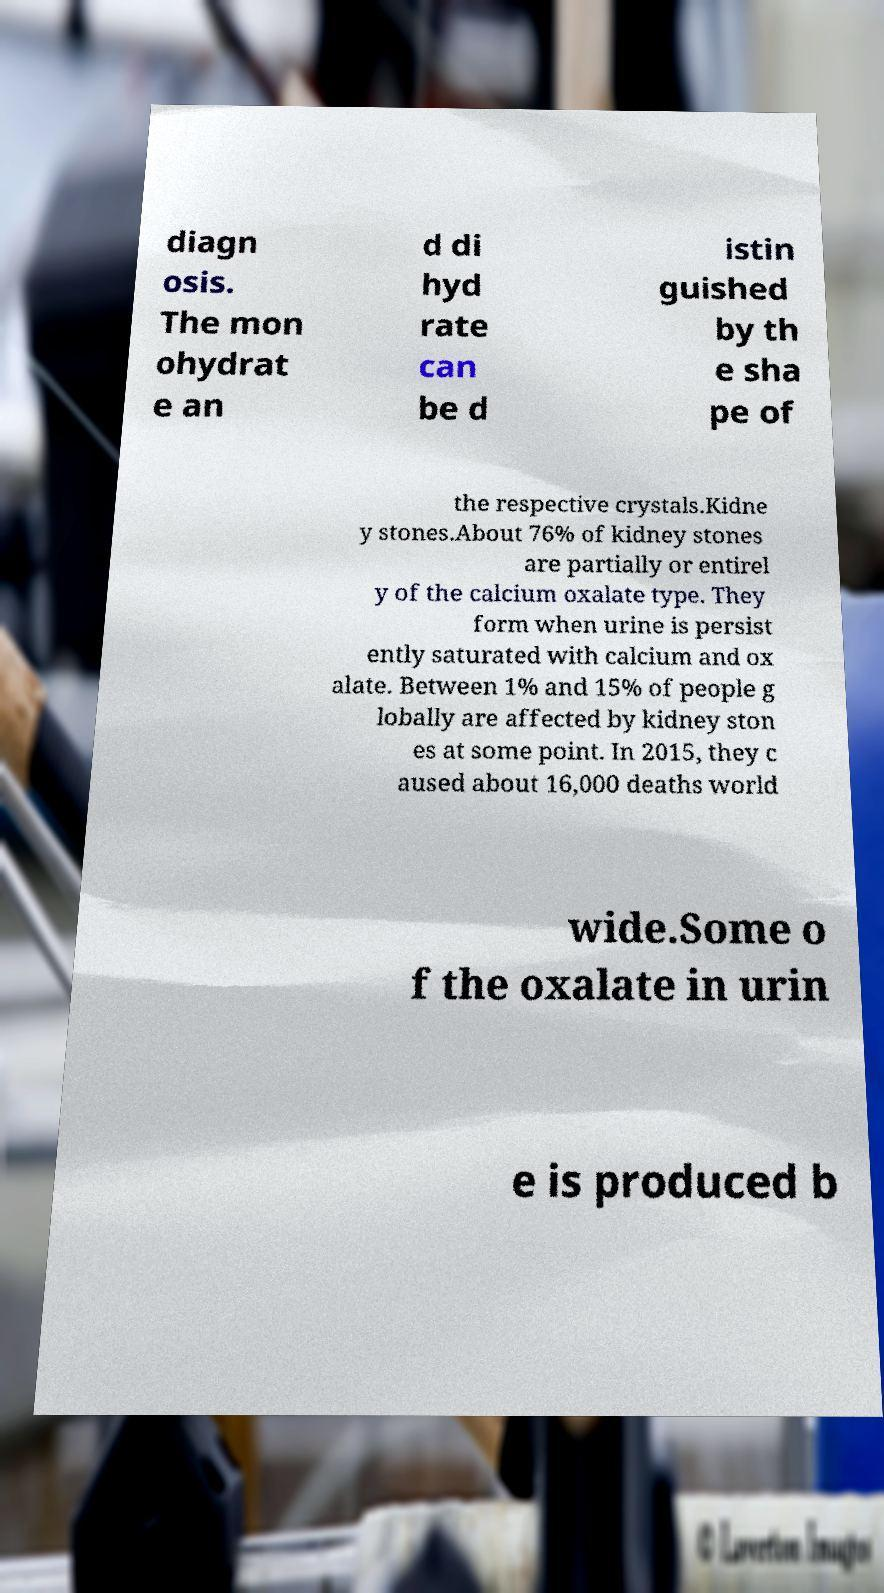Please identify and transcribe the text found in this image. diagn osis. The mon ohydrat e an d di hyd rate can be d istin guished by th e sha pe of the respective crystals.Kidne y stones.About 76% of kidney stones are partially or entirel y of the calcium oxalate type. They form when urine is persist ently saturated with calcium and ox alate. Between 1% and 15% of people g lobally are affected by kidney ston es at some point. In 2015, they c aused about 16,000 deaths world wide.Some o f the oxalate in urin e is produced b 